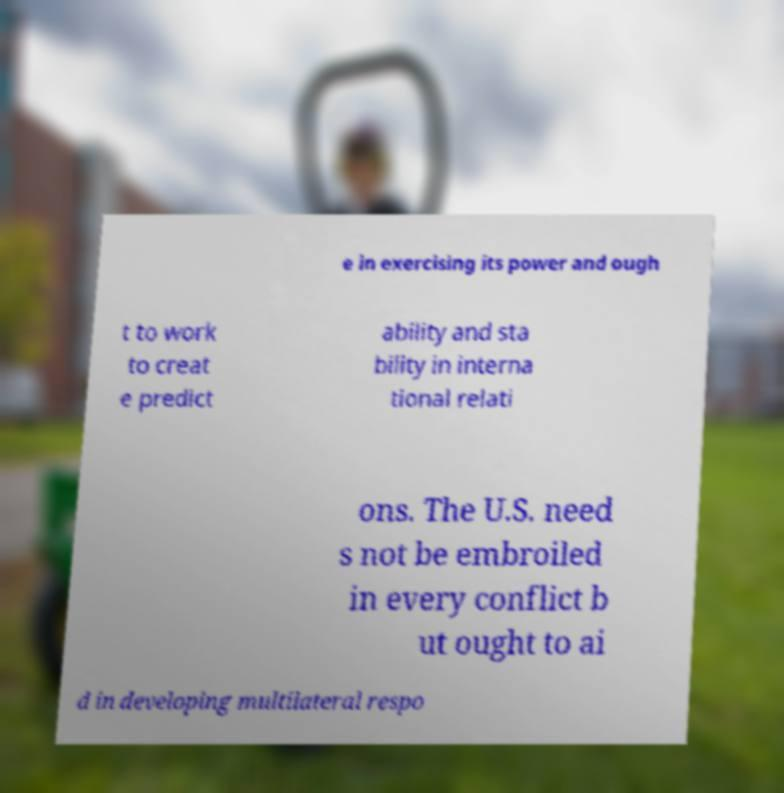Please read and relay the text visible in this image. What does it say? e in exercising its power and ough t to work to creat e predict ability and sta bility in interna tional relati ons. The U.S. need s not be embroiled in every conflict b ut ought to ai d in developing multilateral respo 